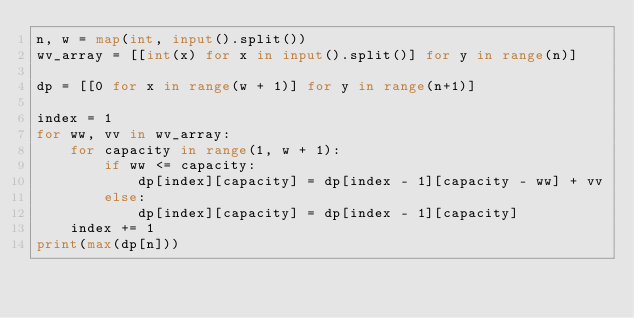Convert code to text. <code><loc_0><loc_0><loc_500><loc_500><_Python_>n, w = map(int, input().split())
wv_array = [[int(x) for x in input().split()] for y in range(n)]

dp = [[0 for x in range(w + 1)] for y in range(n+1)]

index = 1
for ww, vv in wv_array:
    for capacity in range(1, w + 1):
        if ww <= capacity:
            dp[index][capacity] = dp[index - 1][capacity - ww] + vv
        else:
            dp[index][capacity] = dp[index - 1][capacity]
    index += 1
print(max(dp[n]))</code> 